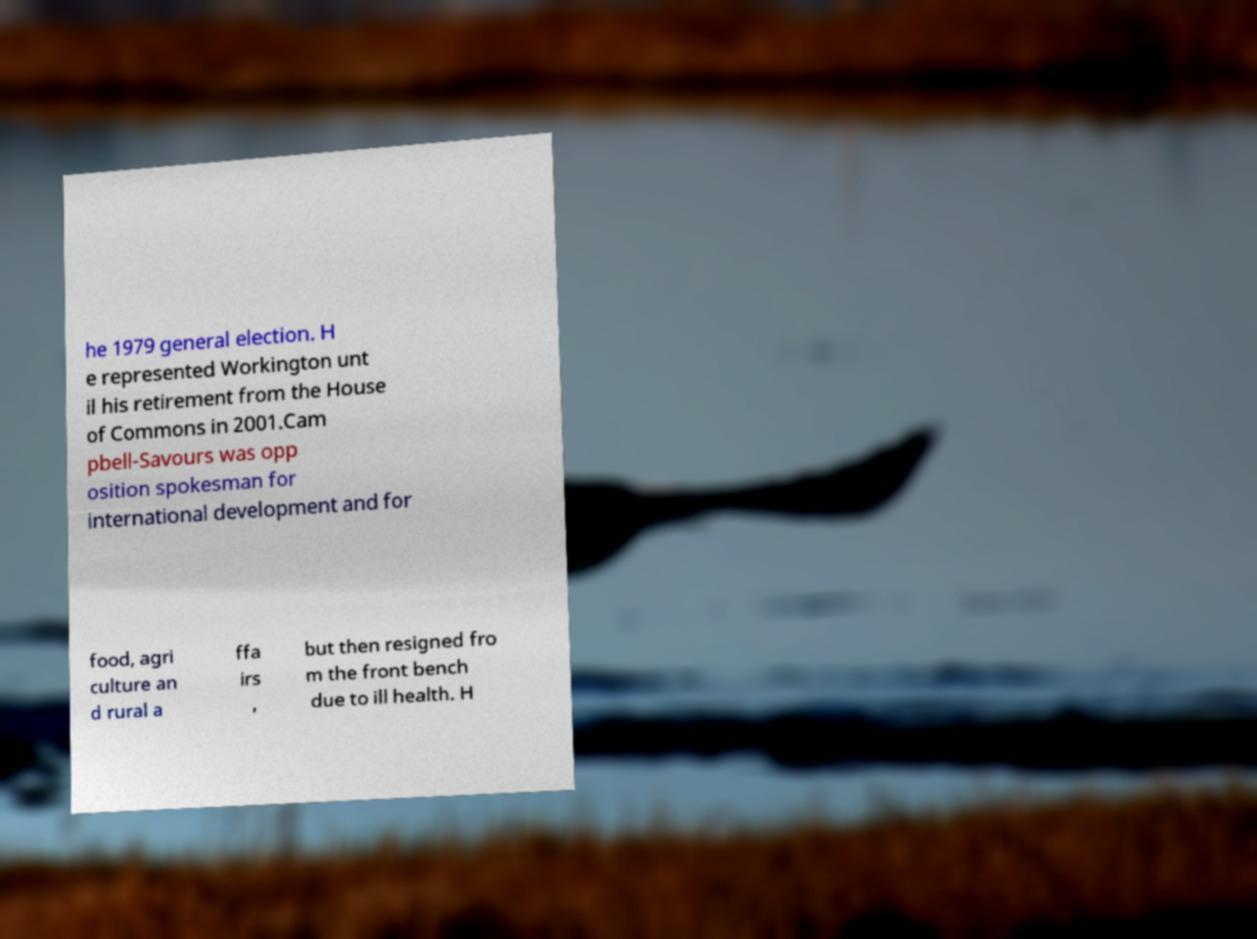Please identify and transcribe the text found in this image. he 1979 general election. H e represented Workington unt il his retirement from the House of Commons in 2001.Cam pbell-Savours was opp osition spokesman for international development and for food, agri culture an d rural a ffa irs , but then resigned fro m the front bench due to ill health. H 